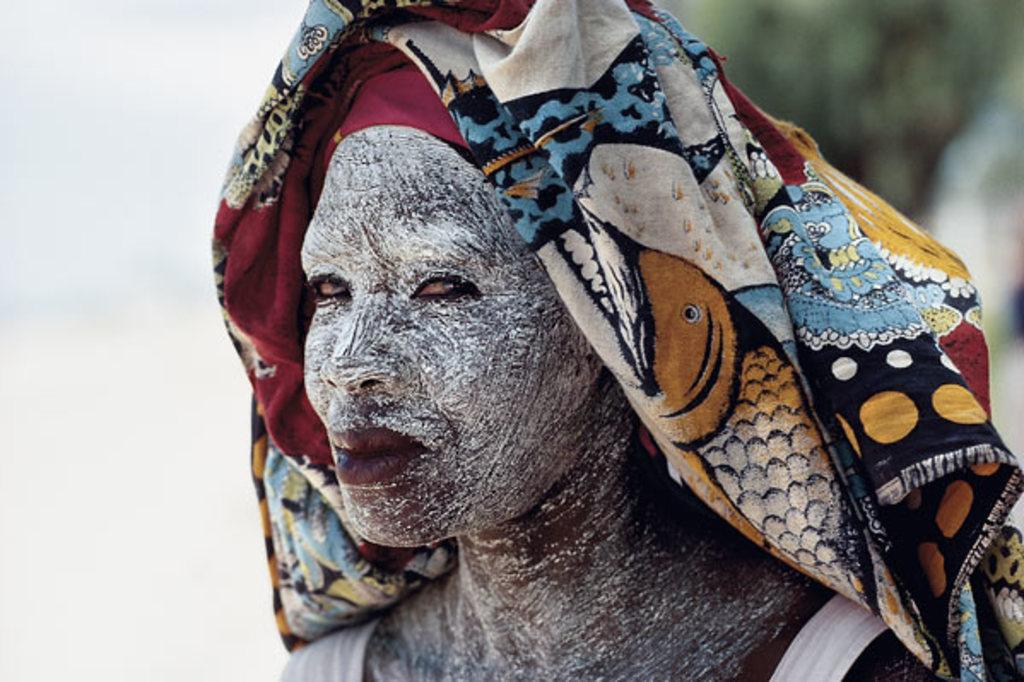What is the main subject of the image? There is a person in the image. What can be observed on the person's face? The person has painting on their face. What type of clothing accessory is the person wearing on their head? The person is wearing a scarf on their head. What type of thrill can be seen in the image? There is no indication of a thrill in the image; it simply shows a person with painted face and a scarf on their head. How many bats are visible in the image? There are no bats present in the image. 